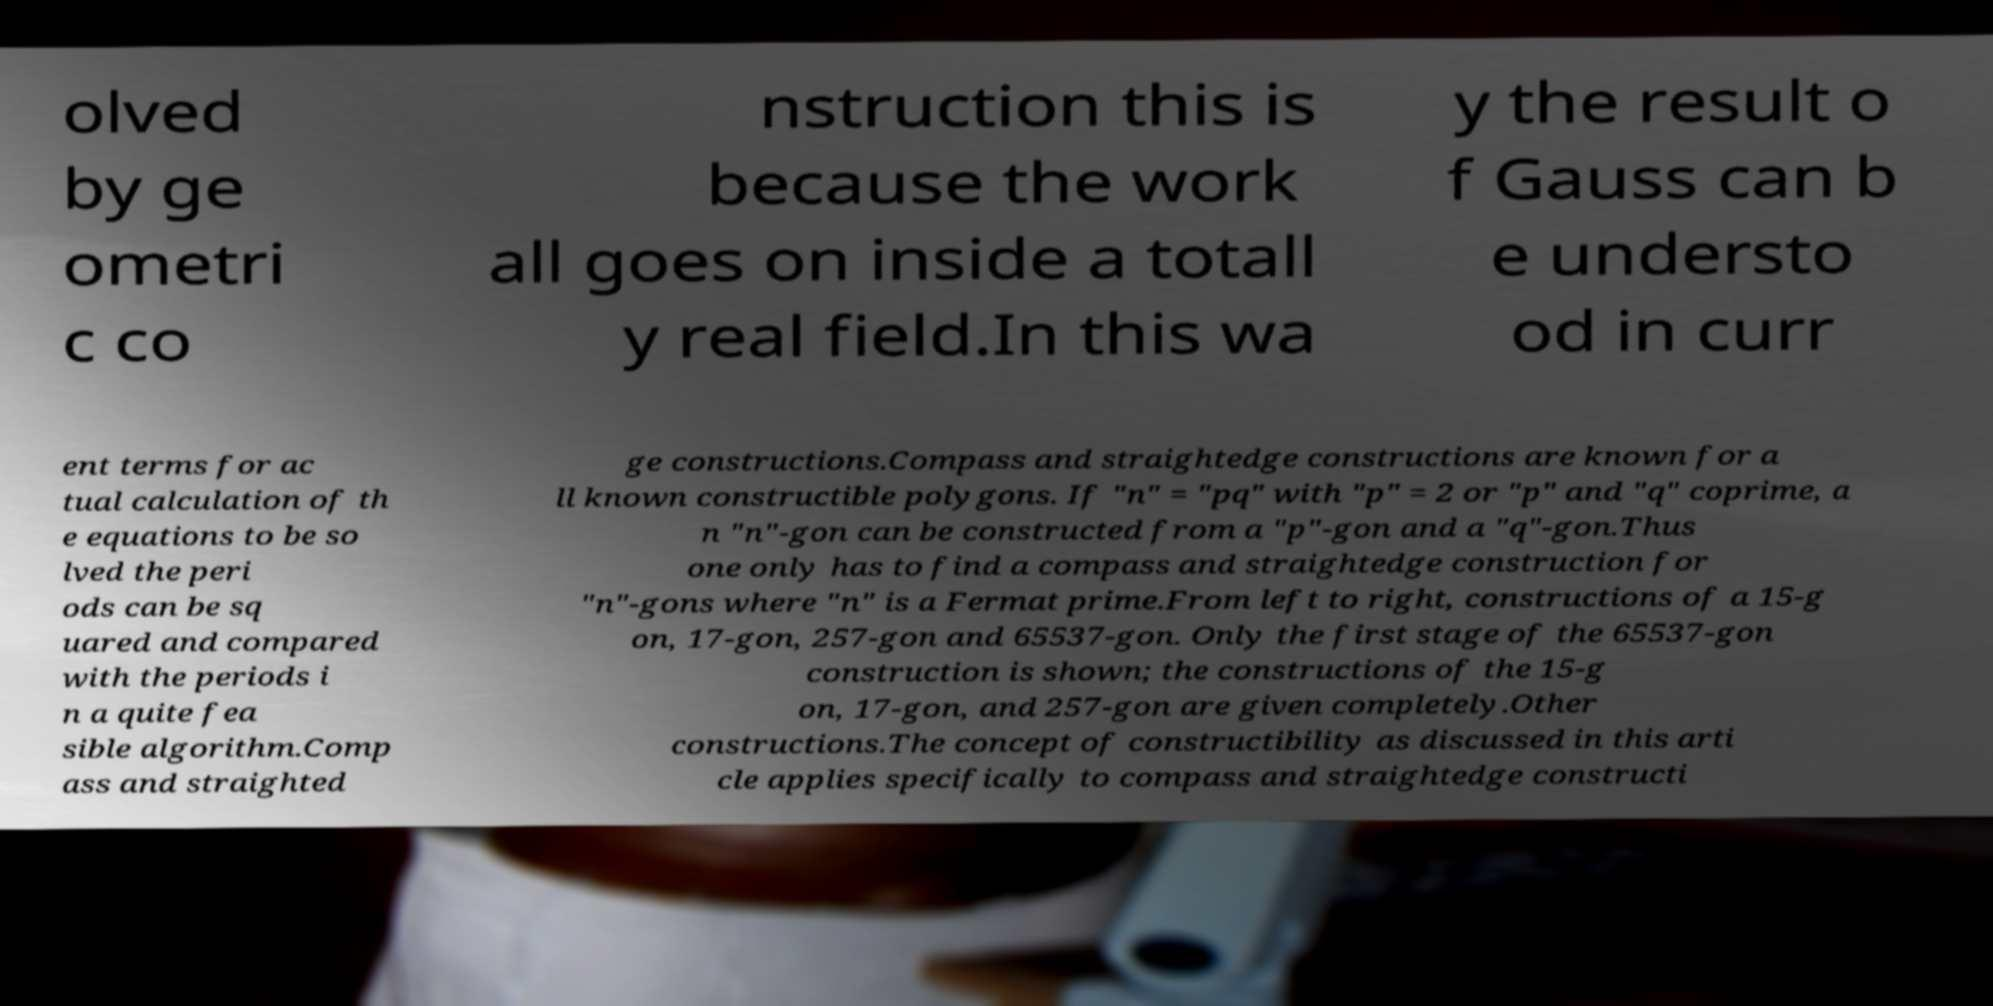What messages or text are displayed in this image? I need them in a readable, typed format. olved by ge ometri c co nstruction this is because the work all goes on inside a totall y real field.In this wa y the result o f Gauss can b e understo od in curr ent terms for ac tual calculation of th e equations to be so lved the peri ods can be sq uared and compared with the periods i n a quite fea sible algorithm.Comp ass and straighted ge constructions.Compass and straightedge constructions are known for a ll known constructible polygons. If "n" = "pq" with "p" = 2 or "p" and "q" coprime, a n "n"-gon can be constructed from a "p"-gon and a "q"-gon.Thus one only has to find a compass and straightedge construction for "n"-gons where "n" is a Fermat prime.From left to right, constructions of a 15-g on, 17-gon, 257-gon and 65537-gon. Only the first stage of the 65537-gon construction is shown; the constructions of the 15-g on, 17-gon, and 257-gon are given completely.Other constructions.The concept of constructibility as discussed in this arti cle applies specifically to compass and straightedge constructi 